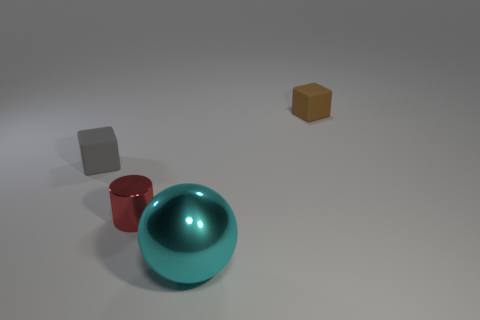Add 1 small cylinders. How many objects exist? 5 Subtract all cylinders. How many objects are left? 3 Add 2 small brown things. How many small brown things are left? 3 Add 3 tiny brown rubber spheres. How many tiny brown rubber spheres exist? 3 Subtract 0 blue cylinders. How many objects are left? 4 Subtract all tiny brown objects. Subtract all cyan spheres. How many objects are left? 2 